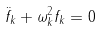Convert formula to latex. <formula><loc_0><loc_0><loc_500><loc_500>\ddot { f } _ { k } + \omega ^ { 2 } _ { k } f _ { k } = 0</formula> 